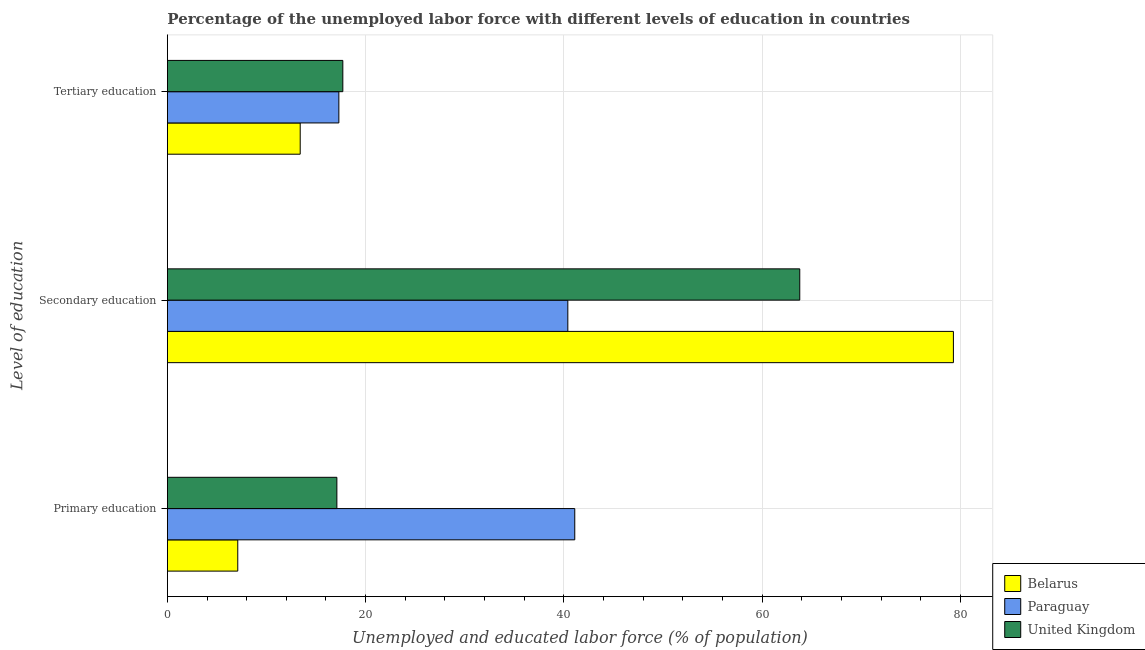How many groups of bars are there?
Your answer should be very brief. 3. What is the label of the 2nd group of bars from the top?
Your answer should be very brief. Secondary education. What is the percentage of labor force who received primary education in Paraguay?
Give a very brief answer. 41.1. Across all countries, what is the maximum percentage of labor force who received tertiary education?
Your answer should be very brief. 17.7. Across all countries, what is the minimum percentage of labor force who received tertiary education?
Your answer should be very brief. 13.4. In which country was the percentage of labor force who received secondary education maximum?
Provide a short and direct response. Belarus. In which country was the percentage of labor force who received primary education minimum?
Make the answer very short. Belarus. What is the total percentage of labor force who received secondary education in the graph?
Offer a terse response. 183.5. What is the difference between the percentage of labor force who received tertiary education in Paraguay and that in Belarus?
Offer a very short reply. 3.9. What is the difference between the percentage of labor force who received primary education in Paraguay and the percentage of labor force who received secondary education in Belarus?
Give a very brief answer. -38.2. What is the average percentage of labor force who received secondary education per country?
Your answer should be very brief. 61.17. What is the difference between the percentage of labor force who received primary education and percentage of labor force who received tertiary education in Belarus?
Give a very brief answer. -6.3. What is the ratio of the percentage of labor force who received primary education in Paraguay to that in United Kingdom?
Provide a short and direct response. 2.4. Is the percentage of labor force who received secondary education in Belarus less than that in Paraguay?
Provide a short and direct response. No. Is the difference between the percentage of labor force who received primary education in Belarus and United Kingdom greater than the difference between the percentage of labor force who received tertiary education in Belarus and United Kingdom?
Provide a short and direct response. No. What is the difference between the highest and the second highest percentage of labor force who received primary education?
Provide a short and direct response. 24. What is the difference between the highest and the lowest percentage of labor force who received primary education?
Offer a terse response. 34. In how many countries, is the percentage of labor force who received primary education greater than the average percentage of labor force who received primary education taken over all countries?
Your answer should be very brief. 1. Is the sum of the percentage of labor force who received tertiary education in Belarus and Paraguay greater than the maximum percentage of labor force who received primary education across all countries?
Give a very brief answer. No. What does the 2nd bar from the top in Tertiary education represents?
Make the answer very short. Paraguay. What does the 3rd bar from the bottom in Tertiary education represents?
Keep it short and to the point. United Kingdom. Are all the bars in the graph horizontal?
Offer a very short reply. Yes. What is the difference between two consecutive major ticks on the X-axis?
Give a very brief answer. 20. How many legend labels are there?
Offer a very short reply. 3. What is the title of the graph?
Your answer should be very brief. Percentage of the unemployed labor force with different levels of education in countries. What is the label or title of the X-axis?
Make the answer very short. Unemployed and educated labor force (% of population). What is the label or title of the Y-axis?
Make the answer very short. Level of education. What is the Unemployed and educated labor force (% of population) in Belarus in Primary education?
Give a very brief answer. 7.1. What is the Unemployed and educated labor force (% of population) in Paraguay in Primary education?
Your answer should be very brief. 41.1. What is the Unemployed and educated labor force (% of population) of United Kingdom in Primary education?
Provide a succinct answer. 17.1. What is the Unemployed and educated labor force (% of population) in Belarus in Secondary education?
Provide a short and direct response. 79.3. What is the Unemployed and educated labor force (% of population) in Paraguay in Secondary education?
Your response must be concise. 40.4. What is the Unemployed and educated labor force (% of population) of United Kingdom in Secondary education?
Make the answer very short. 63.8. What is the Unemployed and educated labor force (% of population) in Belarus in Tertiary education?
Give a very brief answer. 13.4. What is the Unemployed and educated labor force (% of population) in Paraguay in Tertiary education?
Keep it short and to the point. 17.3. What is the Unemployed and educated labor force (% of population) of United Kingdom in Tertiary education?
Your answer should be compact. 17.7. Across all Level of education, what is the maximum Unemployed and educated labor force (% of population) in Belarus?
Ensure brevity in your answer.  79.3. Across all Level of education, what is the maximum Unemployed and educated labor force (% of population) of Paraguay?
Provide a succinct answer. 41.1. Across all Level of education, what is the maximum Unemployed and educated labor force (% of population) in United Kingdom?
Make the answer very short. 63.8. Across all Level of education, what is the minimum Unemployed and educated labor force (% of population) of Belarus?
Make the answer very short. 7.1. Across all Level of education, what is the minimum Unemployed and educated labor force (% of population) in Paraguay?
Keep it short and to the point. 17.3. Across all Level of education, what is the minimum Unemployed and educated labor force (% of population) of United Kingdom?
Ensure brevity in your answer.  17.1. What is the total Unemployed and educated labor force (% of population) of Belarus in the graph?
Provide a short and direct response. 99.8. What is the total Unemployed and educated labor force (% of population) in Paraguay in the graph?
Offer a very short reply. 98.8. What is the total Unemployed and educated labor force (% of population) in United Kingdom in the graph?
Provide a short and direct response. 98.6. What is the difference between the Unemployed and educated labor force (% of population) of Belarus in Primary education and that in Secondary education?
Make the answer very short. -72.2. What is the difference between the Unemployed and educated labor force (% of population) in United Kingdom in Primary education and that in Secondary education?
Provide a succinct answer. -46.7. What is the difference between the Unemployed and educated labor force (% of population) of Belarus in Primary education and that in Tertiary education?
Ensure brevity in your answer.  -6.3. What is the difference between the Unemployed and educated labor force (% of population) of Paraguay in Primary education and that in Tertiary education?
Your response must be concise. 23.8. What is the difference between the Unemployed and educated labor force (% of population) in Belarus in Secondary education and that in Tertiary education?
Your response must be concise. 65.9. What is the difference between the Unemployed and educated labor force (% of population) of Paraguay in Secondary education and that in Tertiary education?
Your response must be concise. 23.1. What is the difference between the Unemployed and educated labor force (% of population) of United Kingdom in Secondary education and that in Tertiary education?
Provide a short and direct response. 46.1. What is the difference between the Unemployed and educated labor force (% of population) of Belarus in Primary education and the Unemployed and educated labor force (% of population) of Paraguay in Secondary education?
Provide a short and direct response. -33.3. What is the difference between the Unemployed and educated labor force (% of population) of Belarus in Primary education and the Unemployed and educated labor force (% of population) of United Kingdom in Secondary education?
Make the answer very short. -56.7. What is the difference between the Unemployed and educated labor force (% of population) of Paraguay in Primary education and the Unemployed and educated labor force (% of population) of United Kingdom in Secondary education?
Keep it short and to the point. -22.7. What is the difference between the Unemployed and educated labor force (% of population) in Belarus in Primary education and the Unemployed and educated labor force (% of population) in United Kingdom in Tertiary education?
Offer a very short reply. -10.6. What is the difference between the Unemployed and educated labor force (% of population) of Paraguay in Primary education and the Unemployed and educated labor force (% of population) of United Kingdom in Tertiary education?
Your response must be concise. 23.4. What is the difference between the Unemployed and educated labor force (% of population) of Belarus in Secondary education and the Unemployed and educated labor force (% of population) of United Kingdom in Tertiary education?
Ensure brevity in your answer.  61.6. What is the difference between the Unemployed and educated labor force (% of population) of Paraguay in Secondary education and the Unemployed and educated labor force (% of population) of United Kingdom in Tertiary education?
Make the answer very short. 22.7. What is the average Unemployed and educated labor force (% of population) of Belarus per Level of education?
Provide a succinct answer. 33.27. What is the average Unemployed and educated labor force (% of population) in Paraguay per Level of education?
Provide a succinct answer. 32.93. What is the average Unemployed and educated labor force (% of population) of United Kingdom per Level of education?
Your answer should be very brief. 32.87. What is the difference between the Unemployed and educated labor force (% of population) in Belarus and Unemployed and educated labor force (% of population) in Paraguay in Primary education?
Give a very brief answer. -34. What is the difference between the Unemployed and educated labor force (% of population) of Belarus and Unemployed and educated labor force (% of population) of Paraguay in Secondary education?
Your answer should be very brief. 38.9. What is the difference between the Unemployed and educated labor force (% of population) in Paraguay and Unemployed and educated labor force (% of population) in United Kingdom in Secondary education?
Your answer should be compact. -23.4. What is the difference between the Unemployed and educated labor force (% of population) in Paraguay and Unemployed and educated labor force (% of population) in United Kingdom in Tertiary education?
Give a very brief answer. -0.4. What is the ratio of the Unemployed and educated labor force (% of population) of Belarus in Primary education to that in Secondary education?
Your response must be concise. 0.09. What is the ratio of the Unemployed and educated labor force (% of population) in Paraguay in Primary education to that in Secondary education?
Provide a short and direct response. 1.02. What is the ratio of the Unemployed and educated labor force (% of population) of United Kingdom in Primary education to that in Secondary education?
Your response must be concise. 0.27. What is the ratio of the Unemployed and educated labor force (% of population) in Belarus in Primary education to that in Tertiary education?
Provide a succinct answer. 0.53. What is the ratio of the Unemployed and educated labor force (% of population) of Paraguay in Primary education to that in Tertiary education?
Keep it short and to the point. 2.38. What is the ratio of the Unemployed and educated labor force (% of population) of United Kingdom in Primary education to that in Tertiary education?
Your answer should be very brief. 0.97. What is the ratio of the Unemployed and educated labor force (% of population) in Belarus in Secondary education to that in Tertiary education?
Keep it short and to the point. 5.92. What is the ratio of the Unemployed and educated labor force (% of population) of Paraguay in Secondary education to that in Tertiary education?
Give a very brief answer. 2.34. What is the ratio of the Unemployed and educated labor force (% of population) in United Kingdom in Secondary education to that in Tertiary education?
Provide a succinct answer. 3.6. What is the difference between the highest and the second highest Unemployed and educated labor force (% of population) of Belarus?
Your response must be concise. 65.9. What is the difference between the highest and the second highest Unemployed and educated labor force (% of population) in United Kingdom?
Offer a very short reply. 46.1. What is the difference between the highest and the lowest Unemployed and educated labor force (% of population) of Belarus?
Your response must be concise. 72.2. What is the difference between the highest and the lowest Unemployed and educated labor force (% of population) in Paraguay?
Your response must be concise. 23.8. What is the difference between the highest and the lowest Unemployed and educated labor force (% of population) in United Kingdom?
Provide a succinct answer. 46.7. 